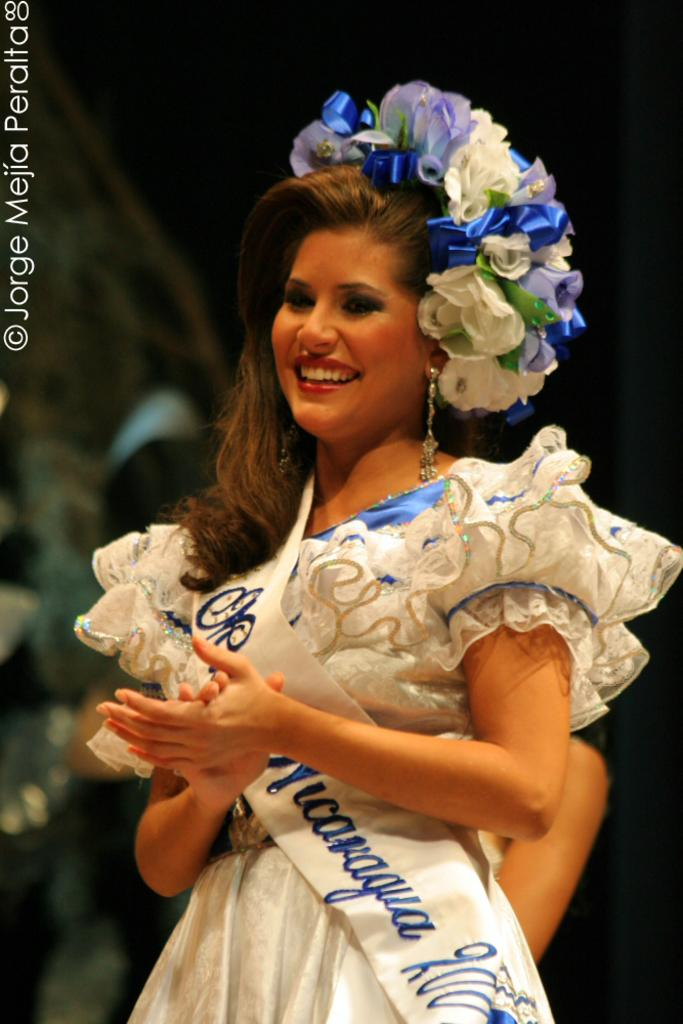Provide a one-sentence caption for the provided image. woman in elegant costume with miss Nicaragua sash and photo copyrighted by jorge mejia peralta. 